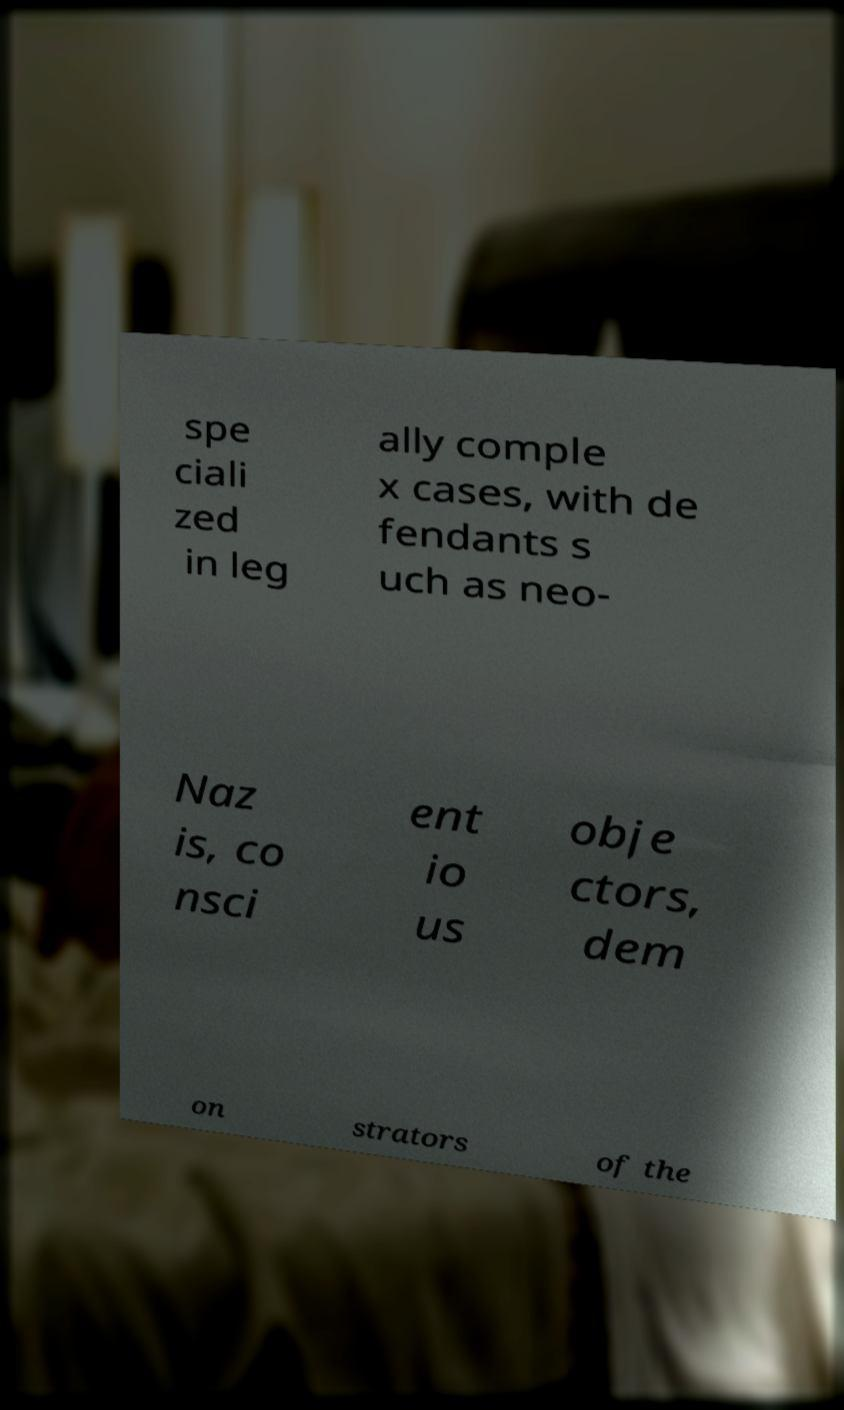What messages or text are displayed in this image? I need them in a readable, typed format. spe ciali zed in leg ally comple x cases, with de fendants s uch as neo- Naz is, co nsci ent io us obje ctors, dem on strators of the 